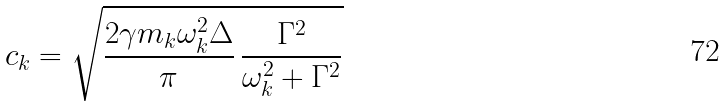<formula> <loc_0><loc_0><loc_500><loc_500>c _ { k } = \sqrt { \frac { 2 \gamma m _ { k } \omega _ { k } ^ { 2 } \Delta } { \pi } \, \frac { \Gamma ^ { 2 } } { \omega _ { k } ^ { 2 } + \Gamma ^ { 2 } } }</formula> 